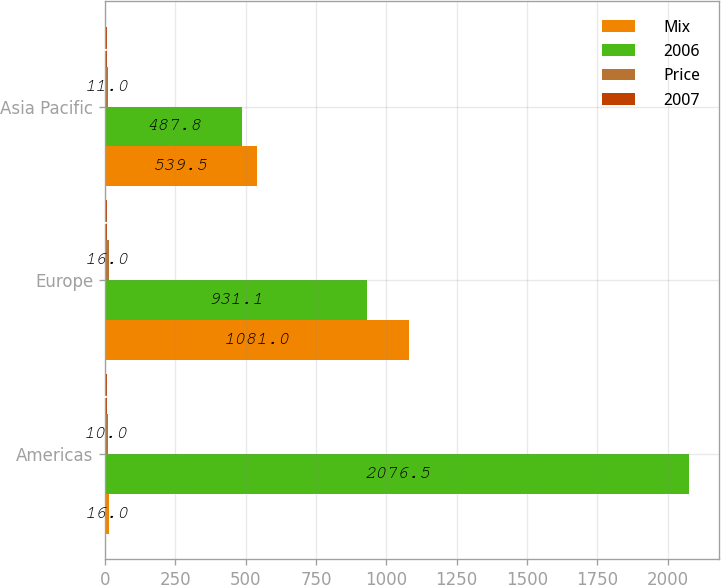Convert chart. <chart><loc_0><loc_0><loc_500><loc_500><stacked_bar_chart><ecel><fcel>Americas<fcel>Europe<fcel>Asia Pacific<nl><fcel>Mix<fcel>16<fcel>1081<fcel>539.5<nl><fcel>2006<fcel>2076.5<fcel>931.1<fcel>487.8<nl><fcel>Price<fcel>10<fcel>16<fcel>11<nl><fcel>2007<fcel>8<fcel>8<fcel>9<nl></chart> 